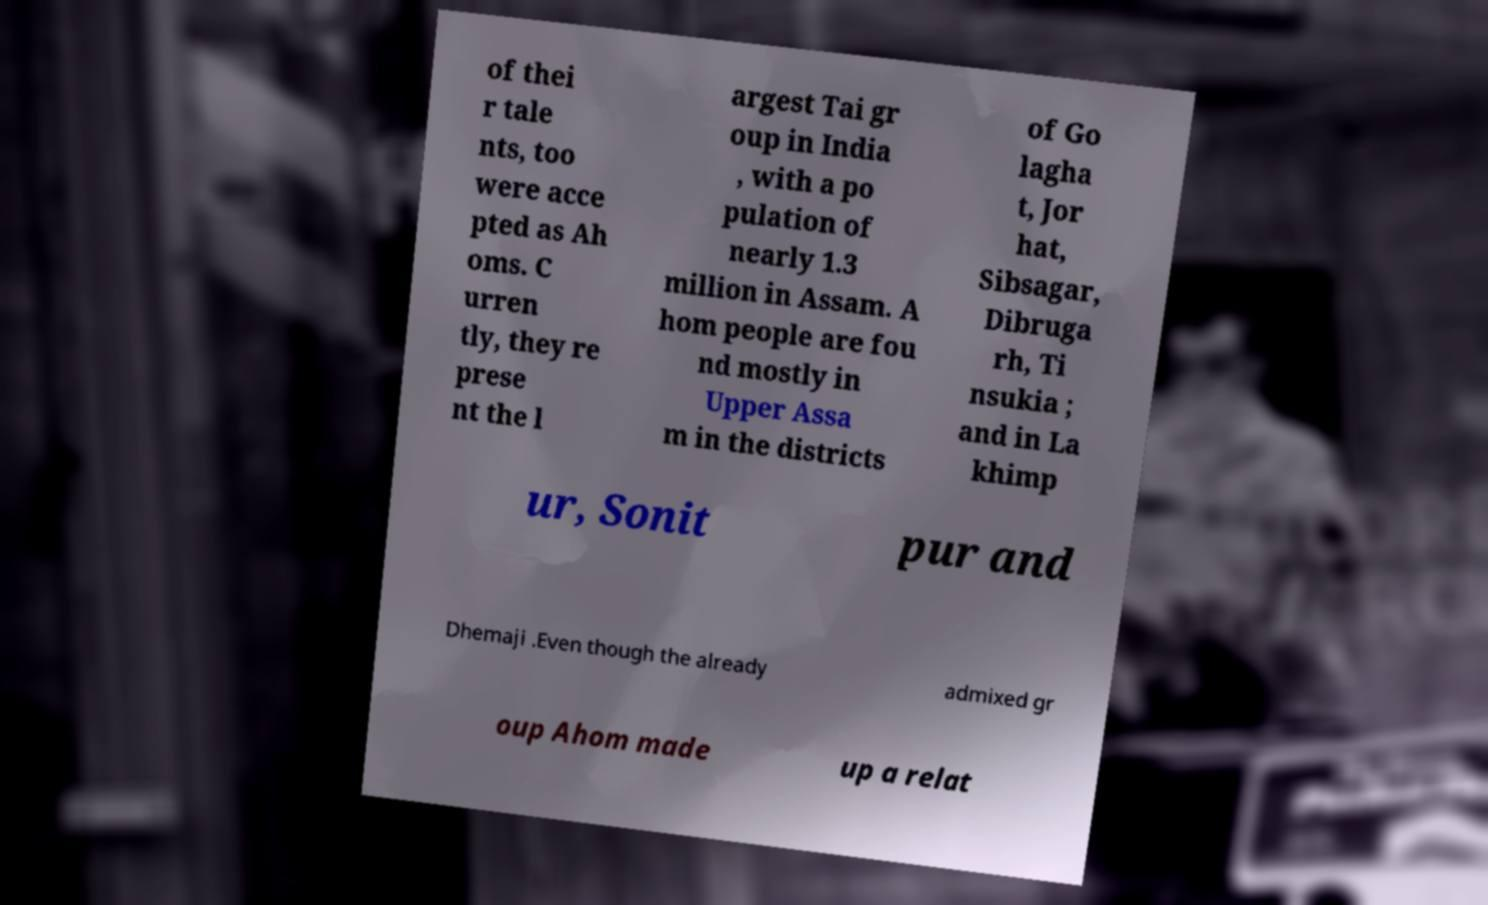Could you assist in decoding the text presented in this image and type it out clearly? of thei r tale nts, too were acce pted as Ah oms. C urren tly, they re prese nt the l argest Tai gr oup in India , with a po pulation of nearly 1.3 million in Assam. A hom people are fou nd mostly in Upper Assa m in the districts of Go lagha t, Jor hat, Sibsagar, Dibruga rh, Ti nsukia ; and in La khimp ur, Sonit pur and Dhemaji .Even though the already admixed gr oup Ahom made up a relat 